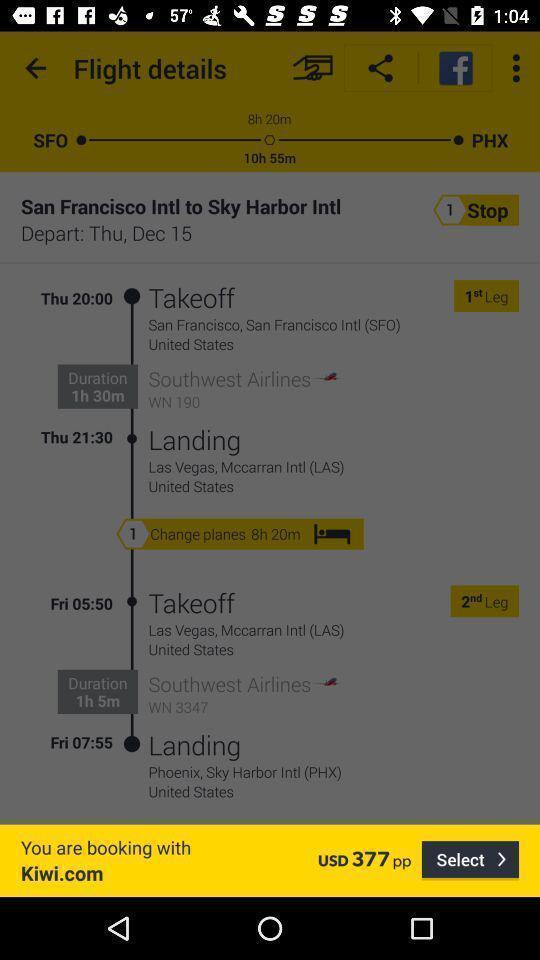Describe this image in words. Window displaying a flight app. 